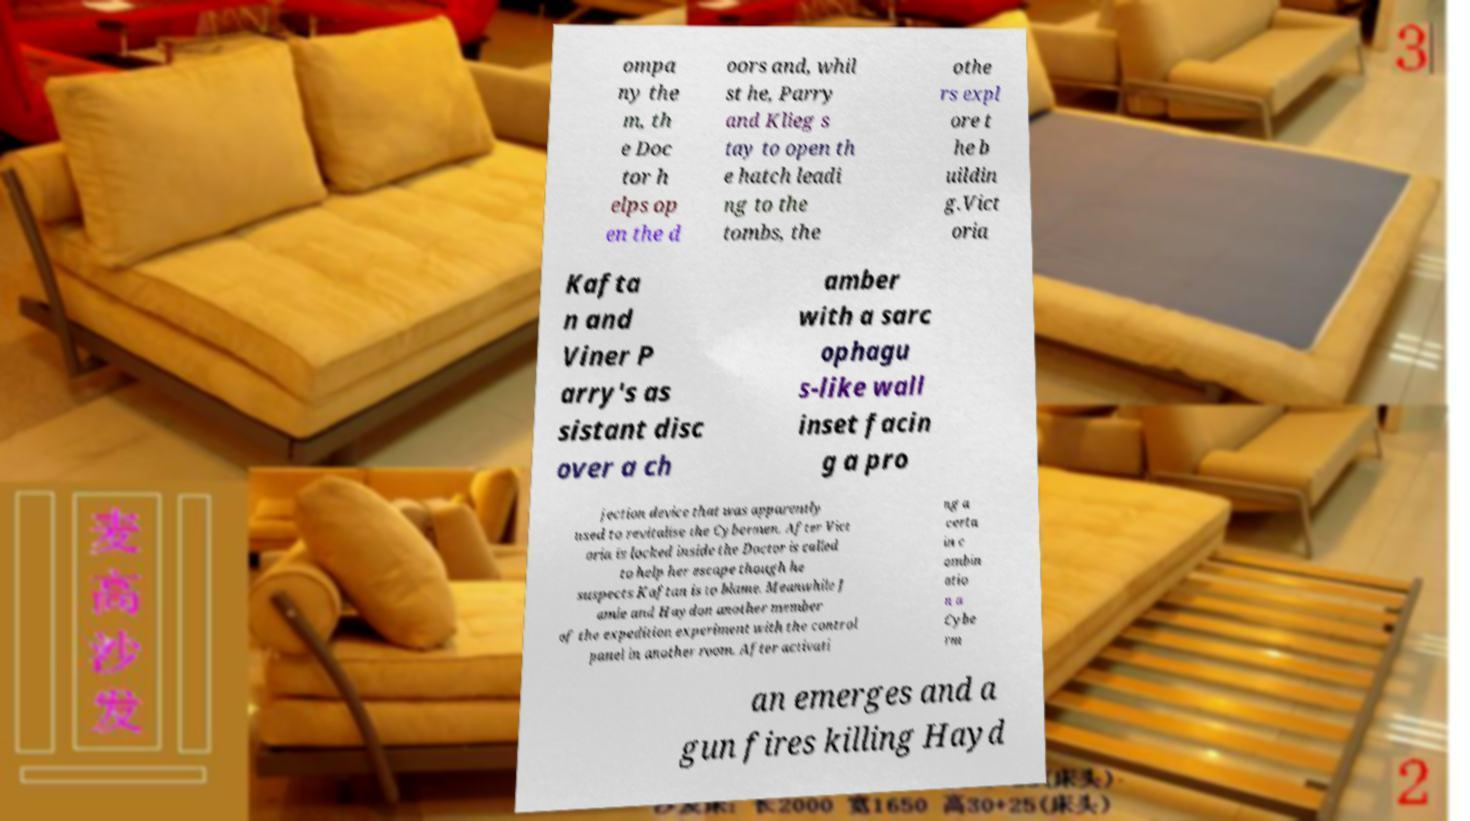What messages or text are displayed in this image? I need them in a readable, typed format. ompa ny the m, th e Doc tor h elps op en the d oors and, whil st he, Parry and Klieg s tay to open th e hatch leadi ng to the tombs, the othe rs expl ore t he b uildin g.Vict oria Kafta n and Viner P arry's as sistant disc over a ch amber with a sarc ophagu s-like wall inset facin g a pro jection device that was apparently used to revitalise the Cybermen. After Vict oria is locked inside the Doctor is called to help her escape though he suspects Kaftan is to blame. Meanwhile J amie and Haydon another member of the expedition experiment with the control panel in another room. After activati ng a certa in c ombin atio n a Cybe rm an emerges and a gun fires killing Hayd 